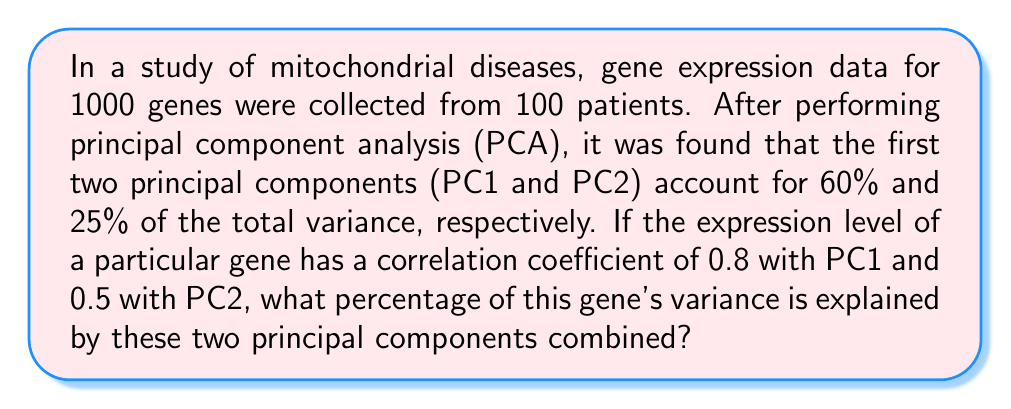Solve this math problem. To solve this problem, we'll follow these steps:

1) In PCA, the total variance explained by a set of principal components is the sum of the squared correlation coefficients between the variable and each principal component.

2) Let's denote the proportion of variance explained by PC1 and PC2 for this particular gene as $R^2$.

3) The formula for $R^2$ is:

   $$R^2 = r_{PC1}^2 + r_{PC2}^2$$

   Where $r_{PC1}$ and $r_{PC2}$ are the correlation coefficients with PC1 and PC2 respectively.

4) We're given that $r_{PC1} = 0.8$ and $r_{PC2} = 0.5$.

5) Let's substitute these values:

   $$R^2 = (0.8)^2 + (0.5)^2$$

6) Calculate:
   
   $$R^2 = 0.64 + 0.25 = 0.89$$

7) Convert to percentage:

   $$R^2 = 0.89 \times 100\% = 89\%$$

Therefore, 89% of this gene's variance is explained by the first two principal components combined.
Answer: 89% 